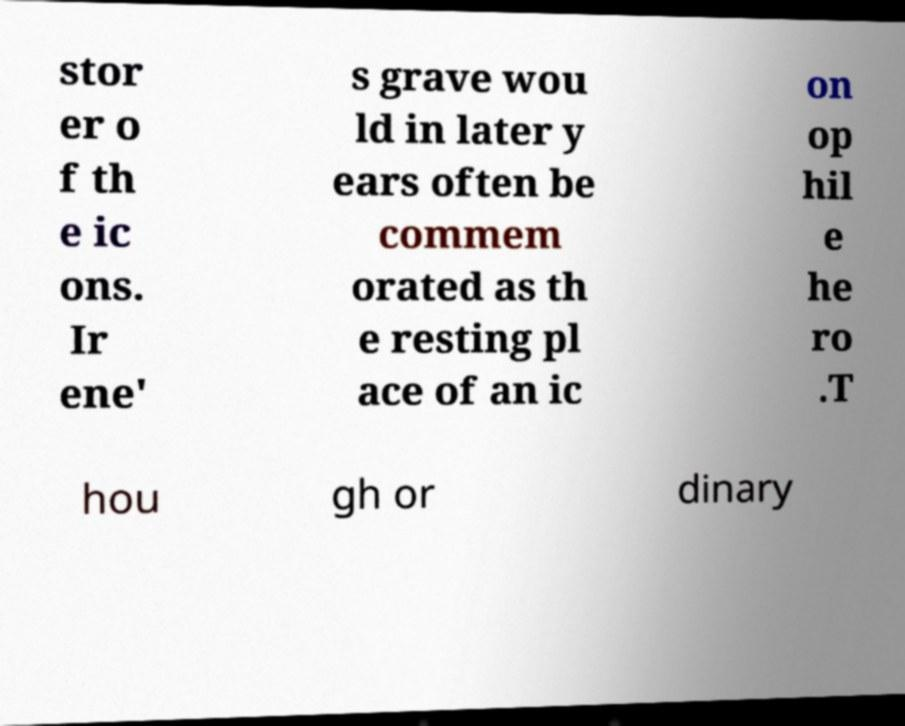There's text embedded in this image that I need extracted. Can you transcribe it verbatim? stor er o f th e ic ons. Ir ene' s grave wou ld in later y ears often be commem orated as th e resting pl ace of an ic on op hil e he ro .T hou gh or dinary 